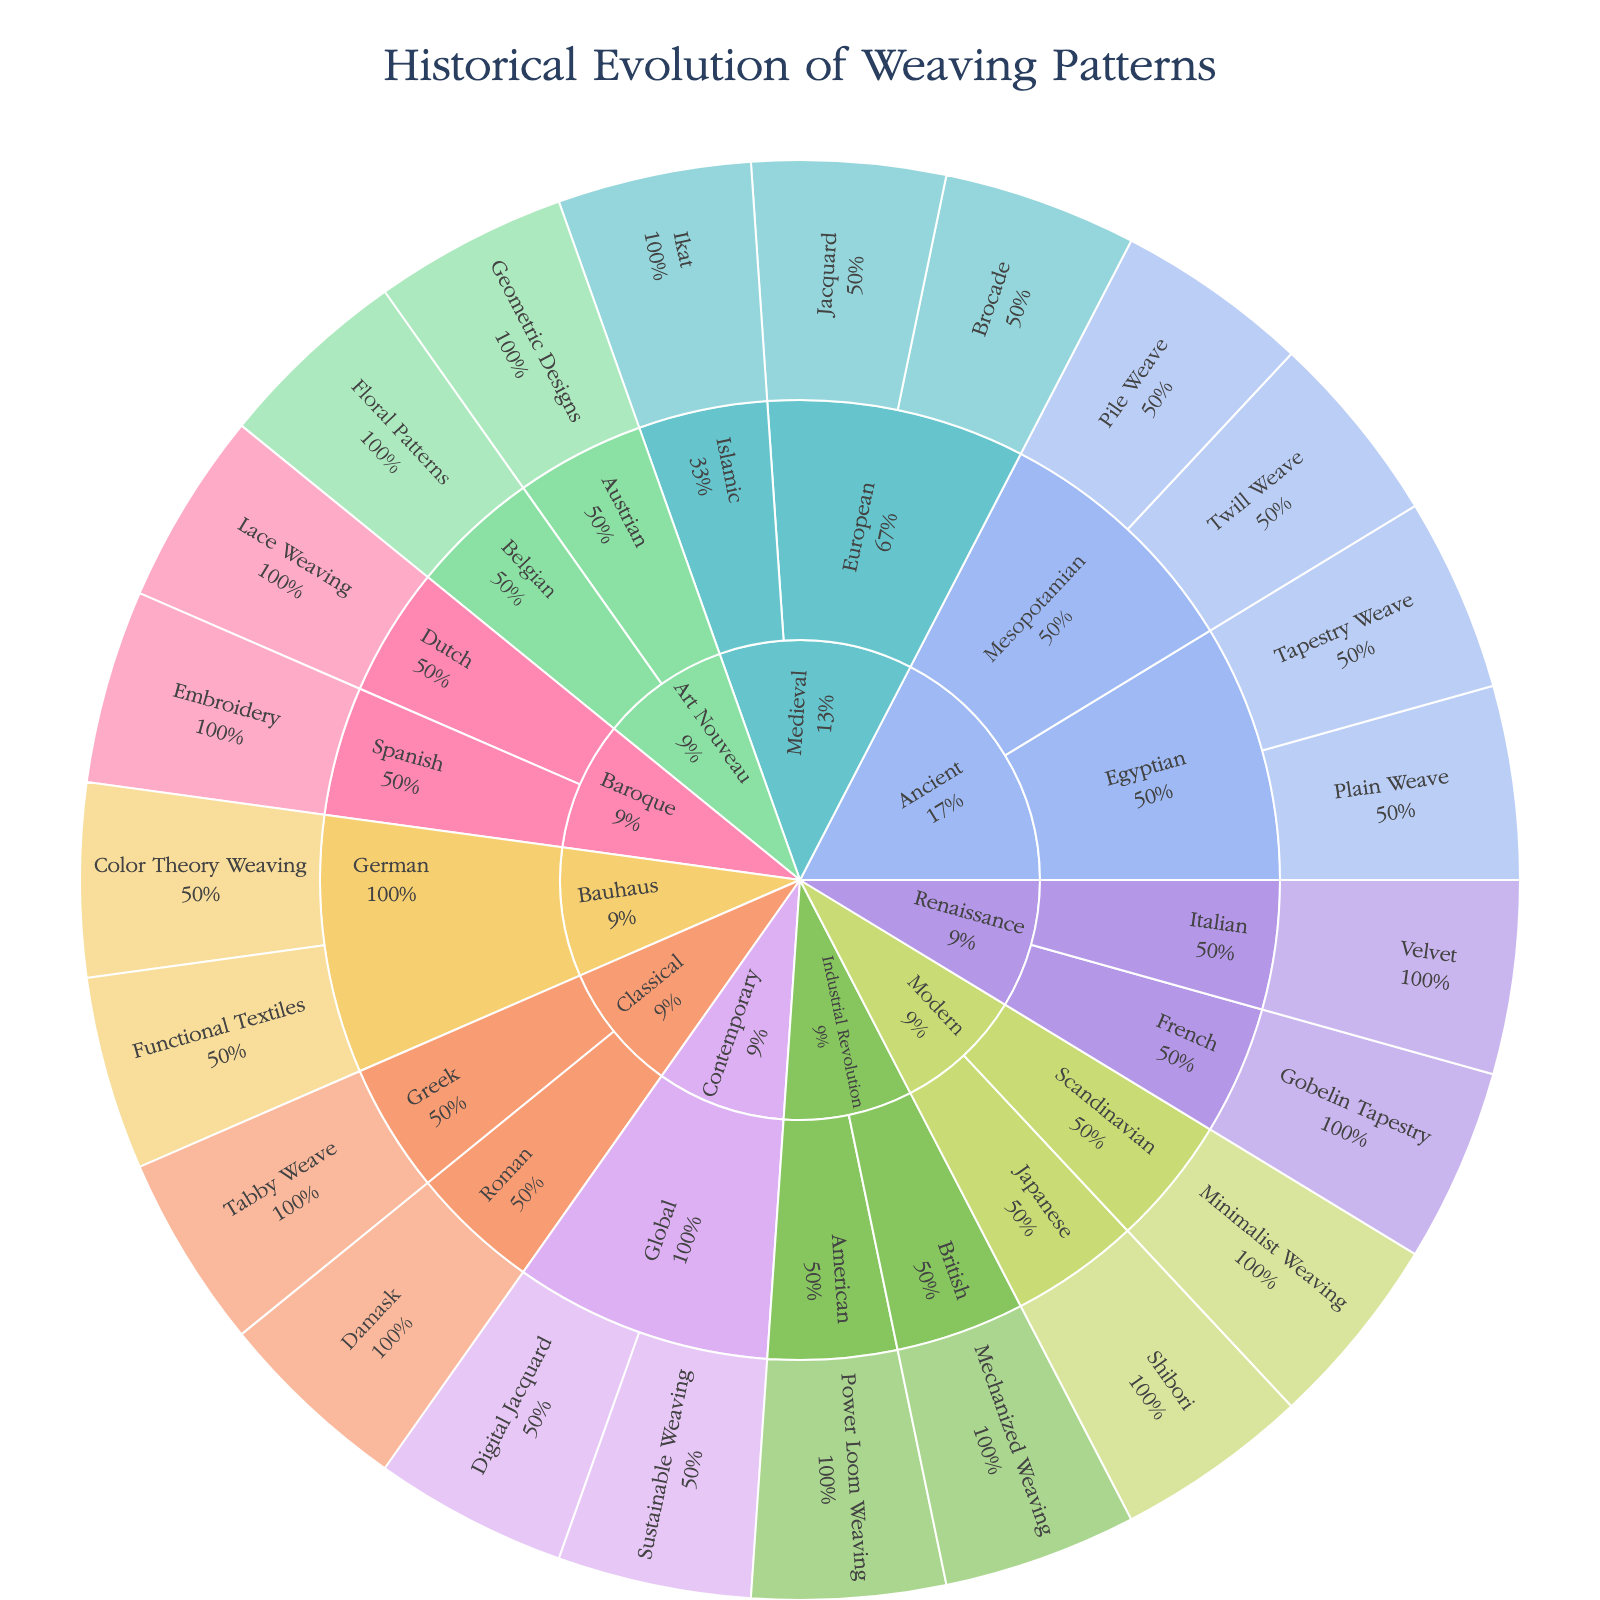What is the title of the plot? The title of the plot is located at the top and centered. It states the primary subject of the visualization.
Answer: Historical Evolution of Weaving Patterns How many weaving techniques are identified under the Medieval time period? Locate the section labeled "Medieval" and count the total weaving techniques listed within this segment.
Answer: Three Which time period has the highest number of weaving techniques listed? Compare the number of weaving techniques under each time period to determine which has the most instances.
Answer: Contemporary Which civilization or movement features "Ikat" as a weaving technique? Trace the path that includes "Ikat" to determine its associated civilization or movement.
Answer: Islamic Is there a weaving technique listed under the Renaissance time period for Italian civilization? Under the Renaissance time period section, look for the Italian civilization and check if there is any weaving technique listed there.
Answer: Yes What is the percentage of weaving techniques under the "Industrial Revolution" relative to its parent? Examine the text information within the "Industrial Revolution" segment to find the percentage.
Answer: 9.1% Compare the number of weaving techniques between the "Art Nouveau" and "Bauhaus" movements. Which one has more techniques listed? Count the total number of techniques listed under each movement and compare the counts.
Answer: Bauhaus Which weaving technique is associated with the Modern time period and Scandinavian civilization? Navigate through the Modern time period to locate the Scandinavian civilization and its respective weaving techniques.
Answer: Minimalist Weaving How many civilizations or movements are represented in the "Ancient" time period? Find the "Ancient" time period and count the distinct civilizations or movements within this section.
Answer: Two Identify one weaving technique that appears under both the Ancient and Classical time periods. Compare the weaving techniques listed under both the Ancient and Classical time periods to find any matching technique.
Answer: None 